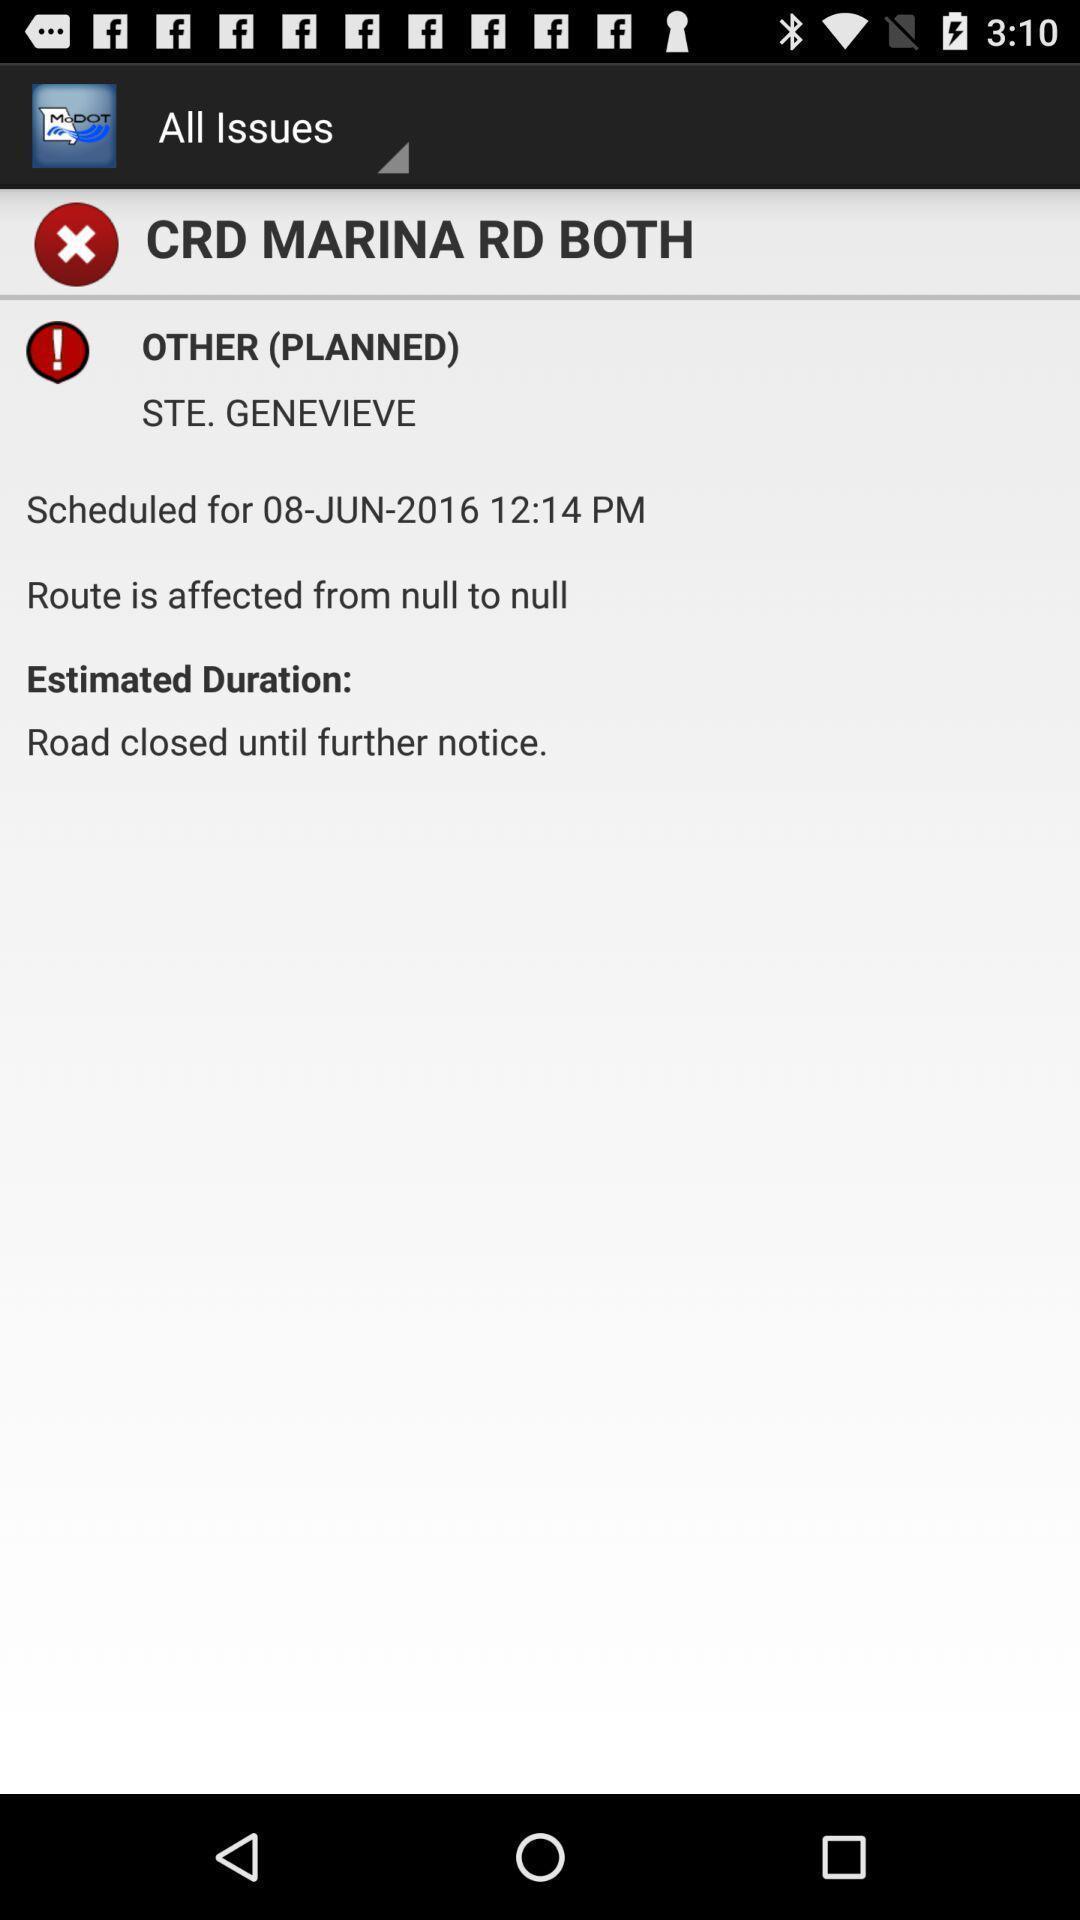Describe this image in words. Screen displaying information about routes. 